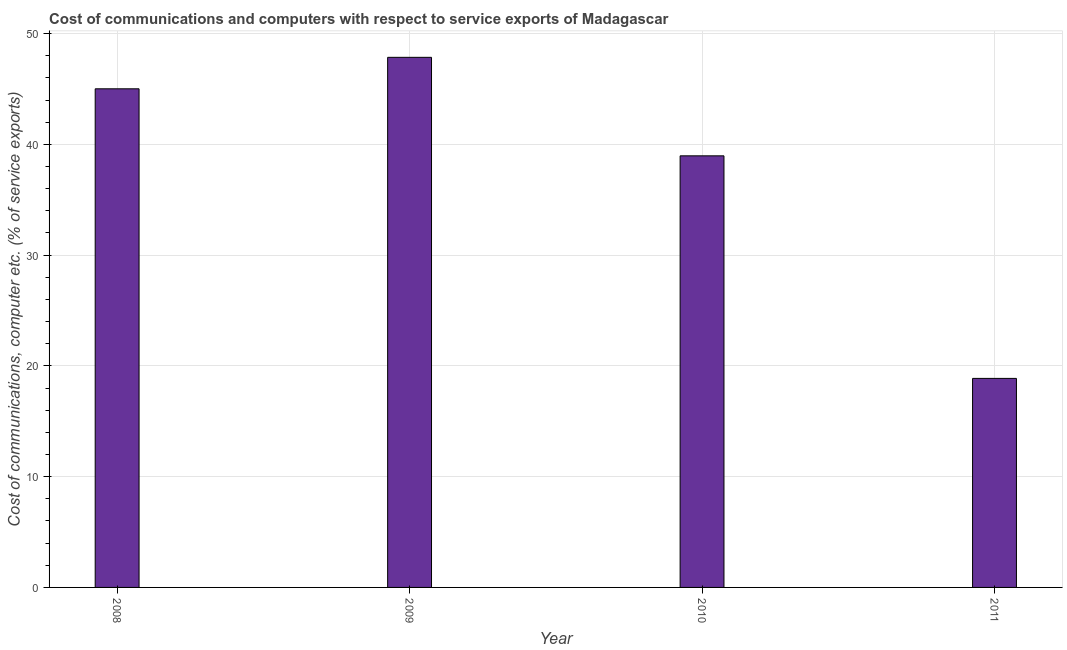Does the graph contain any zero values?
Ensure brevity in your answer.  No. Does the graph contain grids?
Ensure brevity in your answer.  Yes. What is the title of the graph?
Your answer should be very brief. Cost of communications and computers with respect to service exports of Madagascar. What is the label or title of the X-axis?
Keep it short and to the point. Year. What is the label or title of the Y-axis?
Offer a terse response. Cost of communications, computer etc. (% of service exports). What is the cost of communications and computer in 2009?
Keep it short and to the point. 47.86. Across all years, what is the maximum cost of communications and computer?
Offer a terse response. 47.86. Across all years, what is the minimum cost of communications and computer?
Ensure brevity in your answer.  18.87. In which year was the cost of communications and computer maximum?
Give a very brief answer. 2009. In which year was the cost of communications and computer minimum?
Your response must be concise. 2011. What is the sum of the cost of communications and computer?
Provide a succinct answer. 150.71. What is the difference between the cost of communications and computer in 2009 and 2010?
Offer a very short reply. 8.89. What is the average cost of communications and computer per year?
Make the answer very short. 37.68. What is the median cost of communications and computer?
Ensure brevity in your answer.  41.99. In how many years, is the cost of communications and computer greater than 44 %?
Your answer should be compact. 2. Do a majority of the years between 2009 and 2011 (inclusive) have cost of communications and computer greater than 44 %?
Offer a terse response. No. What is the ratio of the cost of communications and computer in 2010 to that in 2011?
Ensure brevity in your answer.  2.06. Is the cost of communications and computer in 2009 less than that in 2010?
Give a very brief answer. No. Is the difference between the cost of communications and computer in 2010 and 2011 greater than the difference between any two years?
Your response must be concise. No. What is the difference between the highest and the second highest cost of communications and computer?
Provide a succinct answer. 2.84. What is the difference between the highest and the lowest cost of communications and computer?
Your answer should be compact. 28.99. In how many years, is the cost of communications and computer greater than the average cost of communications and computer taken over all years?
Keep it short and to the point. 3. How many years are there in the graph?
Provide a succinct answer. 4. What is the Cost of communications, computer etc. (% of service exports) in 2008?
Your answer should be very brief. 45.02. What is the Cost of communications, computer etc. (% of service exports) of 2009?
Make the answer very short. 47.86. What is the Cost of communications, computer etc. (% of service exports) in 2010?
Your answer should be compact. 38.97. What is the Cost of communications, computer etc. (% of service exports) of 2011?
Your response must be concise. 18.87. What is the difference between the Cost of communications, computer etc. (% of service exports) in 2008 and 2009?
Give a very brief answer. -2.84. What is the difference between the Cost of communications, computer etc. (% of service exports) in 2008 and 2010?
Offer a very short reply. 6.05. What is the difference between the Cost of communications, computer etc. (% of service exports) in 2008 and 2011?
Give a very brief answer. 26.15. What is the difference between the Cost of communications, computer etc. (% of service exports) in 2009 and 2010?
Provide a short and direct response. 8.89. What is the difference between the Cost of communications, computer etc. (% of service exports) in 2009 and 2011?
Give a very brief answer. 28.99. What is the difference between the Cost of communications, computer etc. (% of service exports) in 2010 and 2011?
Keep it short and to the point. 20.09. What is the ratio of the Cost of communications, computer etc. (% of service exports) in 2008 to that in 2009?
Give a very brief answer. 0.94. What is the ratio of the Cost of communications, computer etc. (% of service exports) in 2008 to that in 2010?
Your answer should be compact. 1.16. What is the ratio of the Cost of communications, computer etc. (% of service exports) in 2008 to that in 2011?
Keep it short and to the point. 2.38. What is the ratio of the Cost of communications, computer etc. (% of service exports) in 2009 to that in 2010?
Make the answer very short. 1.23. What is the ratio of the Cost of communications, computer etc. (% of service exports) in 2009 to that in 2011?
Your answer should be very brief. 2.54. What is the ratio of the Cost of communications, computer etc. (% of service exports) in 2010 to that in 2011?
Provide a succinct answer. 2.06. 